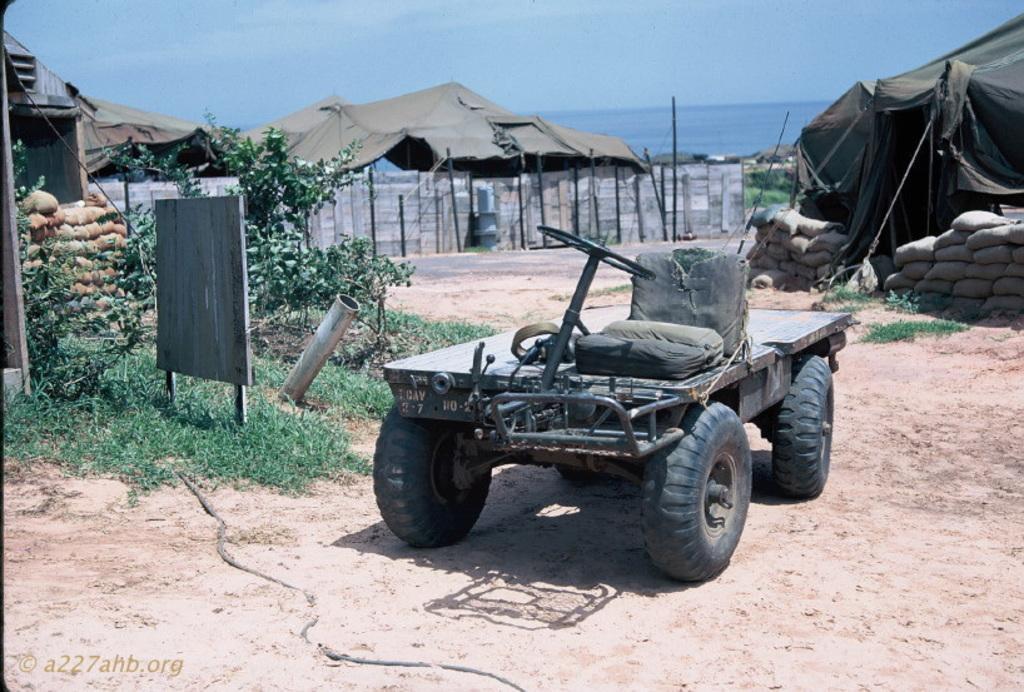Could you give a brief overview of what you see in this image? In this image I can see a vehicle on which there are 2 bags. There are plants, board and sacks on the left. There are many sacks and a tent on the right. There is a tent in the center and there is water behind it. There is sky at the top. 